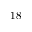Convert formula to latex. <formula><loc_0><loc_0><loc_500><loc_500>1 8</formula> 